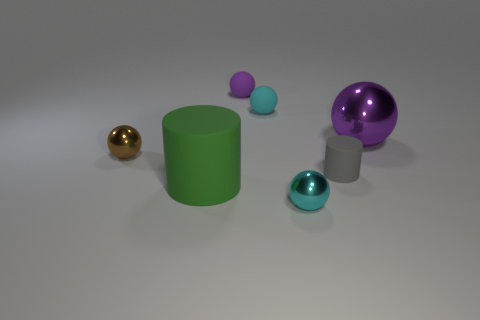Subtract all purple cylinders. How many purple balls are left? 2 Subtract all large spheres. How many spheres are left? 4 Add 1 metallic things. How many objects exist? 8 Subtract all cyan balls. How many balls are left? 3 Subtract all green spheres. Subtract all yellow cylinders. How many spheres are left? 5 Subtract all cylinders. How many objects are left? 5 Add 6 small rubber cylinders. How many small rubber cylinders are left? 7 Add 1 purple spheres. How many purple spheres exist? 3 Subtract 0 cyan blocks. How many objects are left? 7 Subtract all gray cylinders. Subtract all gray rubber objects. How many objects are left? 5 